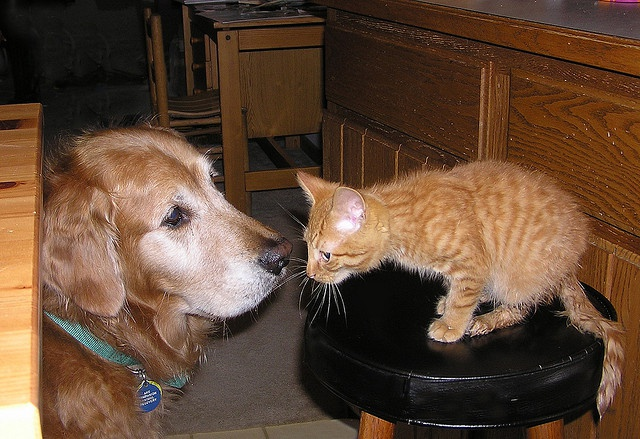Describe the objects in this image and their specific colors. I can see dog in black, gray, maroon, and lightgray tones, chair in black, maroon, gray, and brown tones, cat in black, tan, and gray tones, chair in black, maroon, and gray tones, and chair in black, maroon, and brown tones in this image. 